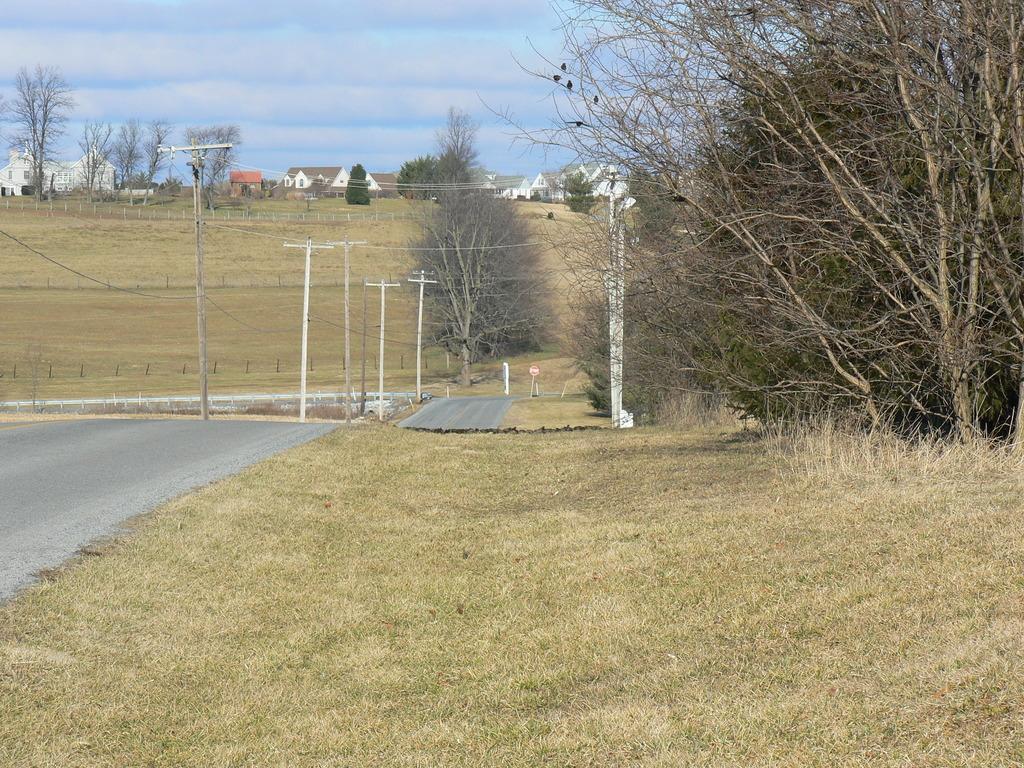In one or two sentences, can you explain what this image depicts? In this image I can see few dry trees, houses, current poles, wires, signboard and the dry grass. The sky is in white and blue color. 